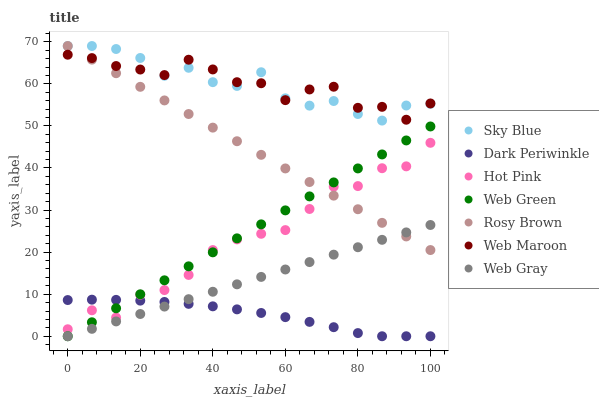Does Dark Periwinkle have the minimum area under the curve?
Answer yes or no. Yes. Does Web Maroon have the maximum area under the curve?
Answer yes or no. Yes. Does Rosy Brown have the minimum area under the curve?
Answer yes or no. No. Does Rosy Brown have the maximum area under the curve?
Answer yes or no. No. Is Web Gray the smoothest?
Answer yes or no. Yes. Is Sky Blue the roughest?
Answer yes or no. Yes. Is Rosy Brown the smoothest?
Answer yes or no. No. Is Rosy Brown the roughest?
Answer yes or no. No. Does Web Green have the lowest value?
Answer yes or no. Yes. Does Rosy Brown have the lowest value?
Answer yes or no. No. Does Sky Blue have the highest value?
Answer yes or no. Yes. Does Web Maroon have the highest value?
Answer yes or no. No. Is Web Gray less than Sky Blue?
Answer yes or no. Yes. Is Hot Pink greater than Web Gray?
Answer yes or no. Yes. Does Hot Pink intersect Dark Periwinkle?
Answer yes or no. Yes. Is Hot Pink less than Dark Periwinkle?
Answer yes or no. No. Is Hot Pink greater than Dark Periwinkle?
Answer yes or no. No. Does Web Gray intersect Sky Blue?
Answer yes or no. No. 